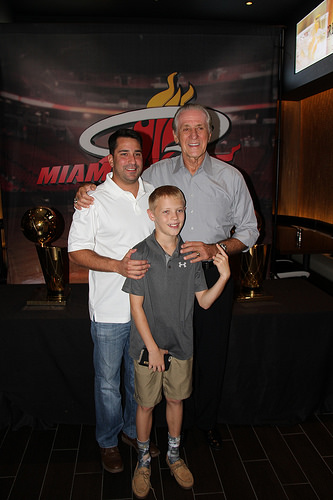<image>
Can you confirm if the trophy is to the right of the father? Yes. From this viewpoint, the trophy is positioned to the right side relative to the father. Is there a man next to the boy? Yes. The man is positioned adjacent to the boy, located nearby in the same general area. Is the boy in front of the man? Yes. The boy is positioned in front of the man, appearing closer to the camera viewpoint. 